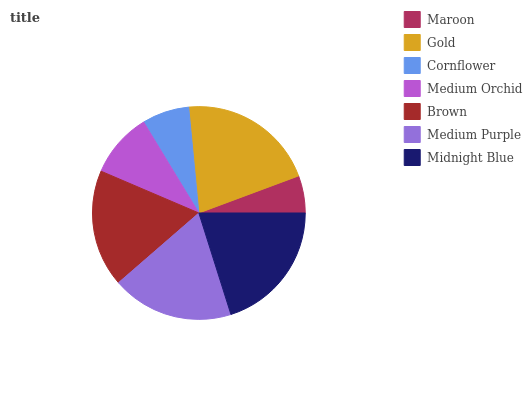Is Maroon the minimum?
Answer yes or no. Yes. Is Gold the maximum?
Answer yes or no. Yes. Is Cornflower the minimum?
Answer yes or no. No. Is Cornflower the maximum?
Answer yes or no. No. Is Gold greater than Cornflower?
Answer yes or no. Yes. Is Cornflower less than Gold?
Answer yes or no. Yes. Is Cornflower greater than Gold?
Answer yes or no. No. Is Gold less than Cornflower?
Answer yes or no. No. Is Brown the high median?
Answer yes or no. Yes. Is Brown the low median?
Answer yes or no. Yes. Is Cornflower the high median?
Answer yes or no. No. Is Midnight Blue the low median?
Answer yes or no. No. 